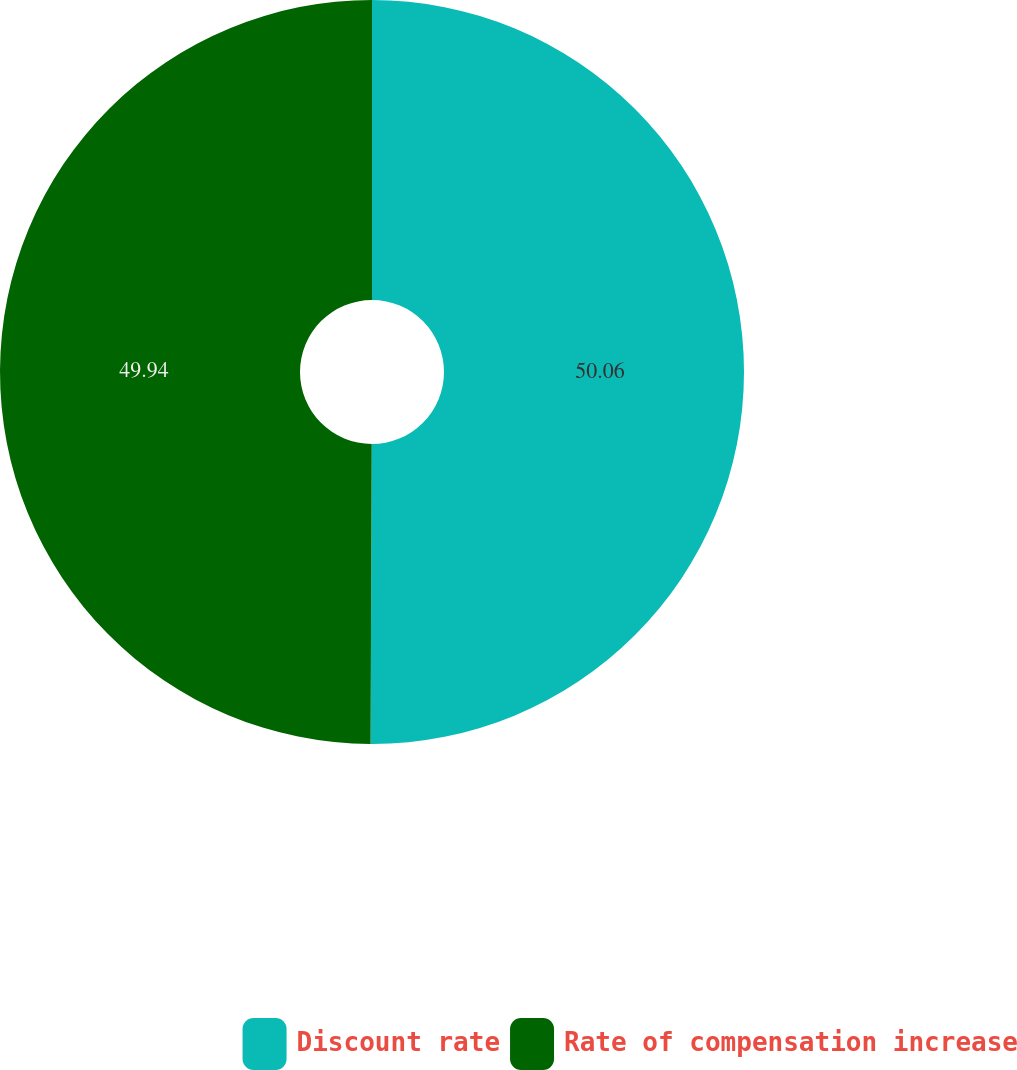Convert chart. <chart><loc_0><loc_0><loc_500><loc_500><pie_chart><fcel>Discount rate<fcel>Rate of compensation increase<nl><fcel>50.06%<fcel>49.94%<nl></chart> 